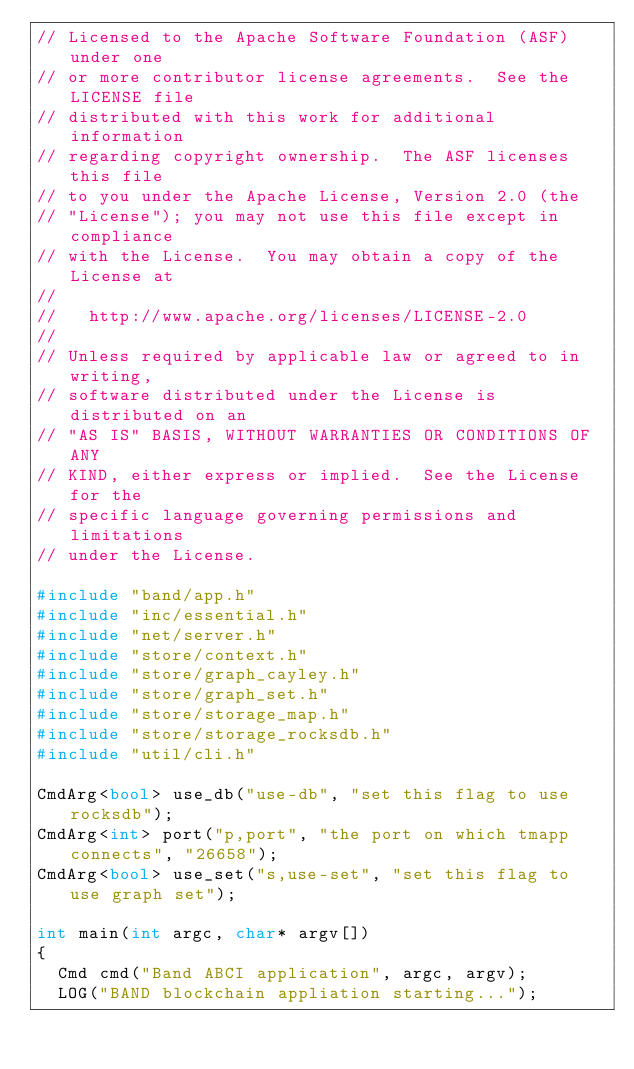Convert code to text. <code><loc_0><loc_0><loc_500><loc_500><_C++_>// Licensed to the Apache Software Foundation (ASF) under one
// or more contributor license agreements.  See the LICENSE file
// distributed with this work for additional information
// regarding copyright ownership.  The ASF licenses this file
// to you under the Apache License, Version 2.0 (the
// "License"); you may not use this file except in compliance
// with the License.  You may obtain a copy of the License at
//
//   http://www.apache.org/licenses/LICENSE-2.0
//
// Unless required by applicable law or agreed to in writing,
// software distributed under the License is distributed on an
// "AS IS" BASIS, WITHOUT WARRANTIES OR CONDITIONS OF ANY
// KIND, either express or implied.  See the License for the
// specific language governing permissions and limitations
// under the License.

#include "band/app.h"
#include "inc/essential.h"
#include "net/server.h"
#include "store/context.h"
#include "store/graph_cayley.h"
#include "store/graph_set.h"
#include "store/storage_map.h"
#include "store/storage_rocksdb.h"
#include "util/cli.h"

CmdArg<bool> use_db("use-db", "set this flag to use rocksdb");
CmdArg<int> port("p,port", "the port on which tmapp connects", "26658");
CmdArg<bool> use_set("s,use-set", "set this flag to use graph set");

int main(int argc, char* argv[])
{
  Cmd cmd("Band ABCI application", argc, argv);
  LOG("BAND blockchain appliation starting...");
</code> 